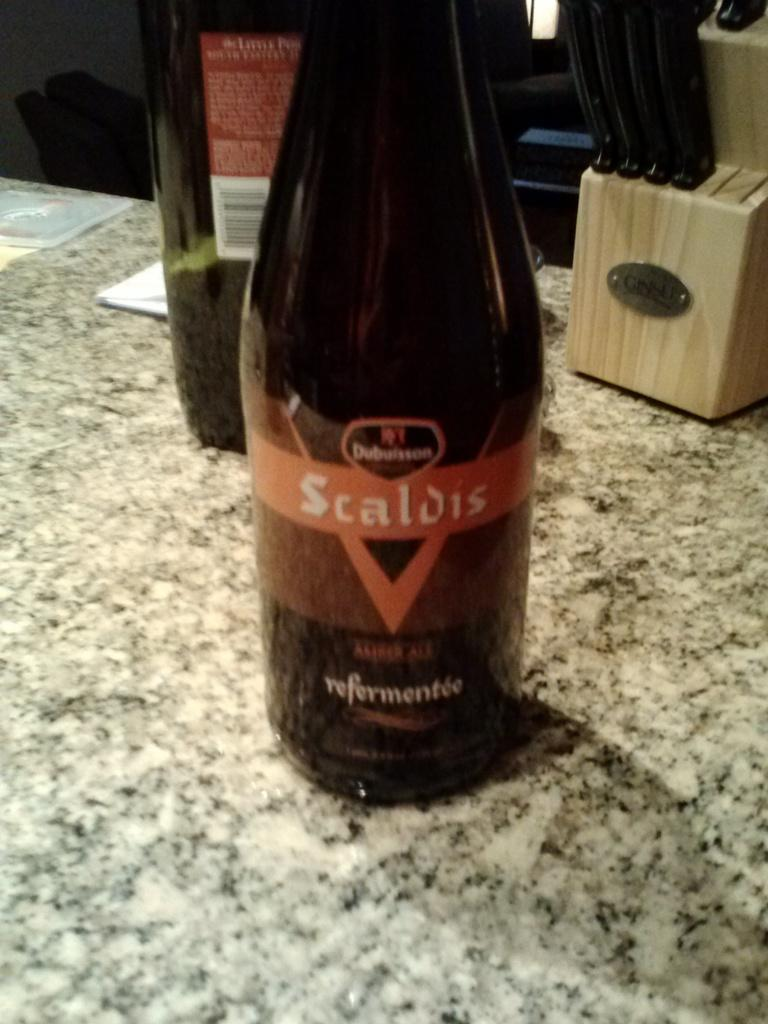<image>
Describe the image concisely. A bottle with an orange and black label that reads scaldis on it. 